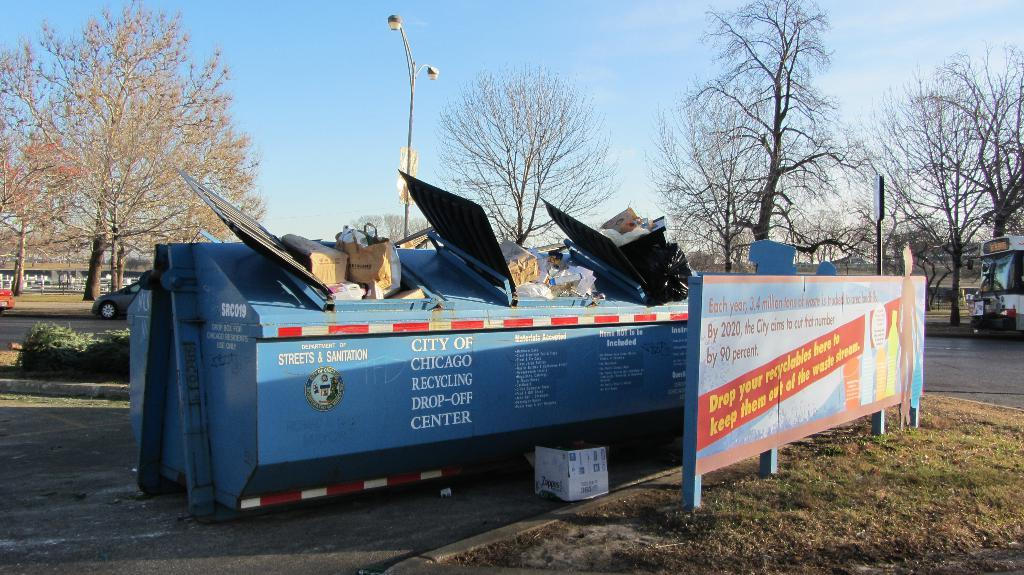<image>
Offer a succinct explanation of the picture presented. The Recycling Center drop off site in Chicago is full of recyclables. 